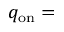<formula> <loc_0><loc_0><loc_500><loc_500>q _ { o n } =</formula> 